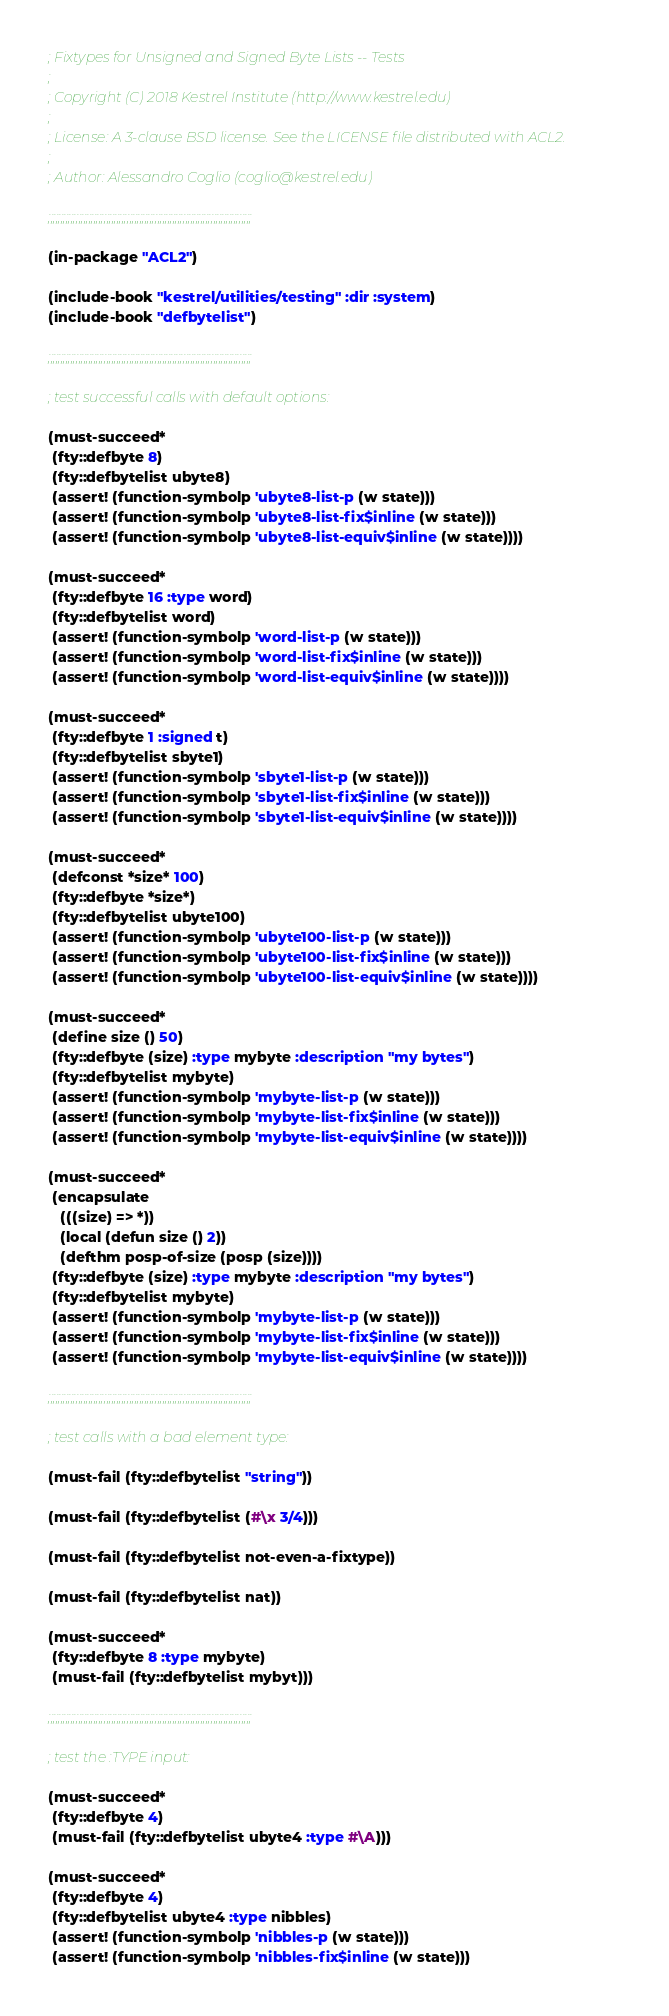<code> <loc_0><loc_0><loc_500><loc_500><_Lisp_>; Fixtypes for Unsigned and Signed Byte Lists -- Tests
;
; Copyright (C) 2018 Kestrel Institute (http://www.kestrel.edu)
;
; License: A 3-clause BSD license. See the LICENSE file distributed with ACL2.
;
; Author: Alessandro Coglio (coglio@kestrel.edu)

;;;;;;;;;;;;;;;;;;;;;;;;;;;;;;;;;;;;;;;;;;;;;;;;;;;;;;;;;;;;;;;;;;;;;;;;;;;;;;;;

(in-package "ACL2")

(include-book "kestrel/utilities/testing" :dir :system)
(include-book "defbytelist")

;;;;;;;;;;;;;;;;;;;;;;;;;;;;;;;;;;;;;;;;;;;;;;;;;;;;;;;;;;;;;;;;;;;;;;;;;;;;;;;;

; test successful calls with default options:

(must-succeed*
 (fty::defbyte 8)
 (fty::defbytelist ubyte8)
 (assert! (function-symbolp 'ubyte8-list-p (w state)))
 (assert! (function-symbolp 'ubyte8-list-fix$inline (w state)))
 (assert! (function-symbolp 'ubyte8-list-equiv$inline (w state))))

(must-succeed*
 (fty::defbyte 16 :type word)
 (fty::defbytelist word)
 (assert! (function-symbolp 'word-list-p (w state)))
 (assert! (function-symbolp 'word-list-fix$inline (w state)))
 (assert! (function-symbolp 'word-list-equiv$inline (w state))))

(must-succeed*
 (fty::defbyte 1 :signed t)
 (fty::defbytelist sbyte1)
 (assert! (function-symbolp 'sbyte1-list-p (w state)))
 (assert! (function-symbolp 'sbyte1-list-fix$inline (w state)))
 (assert! (function-symbolp 'sbyte1-list-equiv$inline (w state))))

(must-succeed*
 (defconst *size* 100)
 (fty::defbyte *size*)
 (fty::defbytelist ubyte100)
 (assert! (function-symbolp 'ubyte100-list-p (w state)))
 (assert! (function-symbolp 'ubyte100-list-fix$inline (w state)))
 (assert! (function-symbolp 'ubyte100-list-equiv$inline (w state))))

(must-succeed*
 (define size () 50)
 (fty::defbyte (size) :type mybyte :description "my bytes")
 (fty::defbytelist mybyte)
 (assert! (function-symbolp 'mybyte-list-p (w state)))
 (assert! (function-symbolp 'mybyte-list-fix$inline (w state)))
 (assert! (function-symbolp 'mybyte-list-equiv$inline (w state))))

(must-succeed*
 (encapsulate
   (((size) => *))
   (local (defun size () 2))
   (defthm posp-of-size (posp (size))))
 (fty::defbyte (size) :type mybyte :description "my bytes")
 (fty::defbytelist mybyte)
 (assert! (function-symbolp 'mybyte-list-p (w state)))
 (assert! (function-symbolp 'mybyte-list-fix$inline (w state)))
 (assert! (function-symbolp 'mybyte-list-equiv$inline (w state))))

;;;;;;;;;;;;;;;;;;;;;;;;;;;;;;;;;;;;;;;;;;;;;;;;;;;;;;;;;;;;;;;;;;;;;;;;;;;;;;;;

; test calls with a bad element type:

(must-fail (fty::defbytelist "string"))

(must-fail (fty::defbytelist (#\x 3/4)))

(must-fail (fty::defbytelist not-even-a-fixtype))

(must-fail (fty::defbytelist nat))

(must-succeed*
 (fty::defbyte 8 :type mybyte)
 (must-fail (fty::defbytelist mybyt)))

;;;;;;;;;;;;;;;;;;;;;;;;;;;;;;;;;;;;;;;;;;;;;;;;;;;;;;;;;;;;;;;;;;;;;;;;;;;;;;;;

; test the :TYPE input:

(must-succeed*
 (fty::defbyte 4)
 (must-fail (fty::defbytelist ubyte4 :type #\A)))

(must-succeed*
 (fty::defbyte 4)
 (fty::defbytelist ubyte4 :type nibbles)
 (assert! (function-symbolp 'nibbles-p (w state)))
 (assert! (function-symbolp 'nibbles-fix$inline (w state)))</code> 